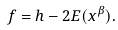<formula> <loc_0><loc_0><loc_500><loc_500>f = h - 2 E ( x ^ { \beta } ) .</formula> 